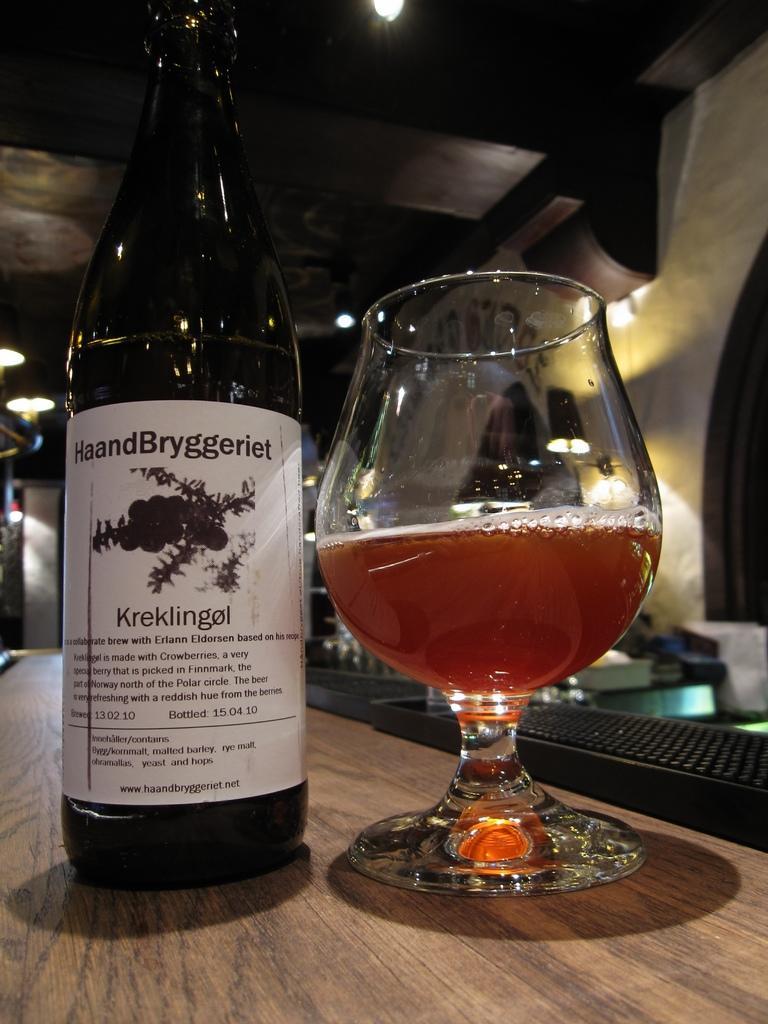Can you describe this image briefly? In this image we can see a bottle with sticker and a glass with drink on the table, and also we can see some other objects. 